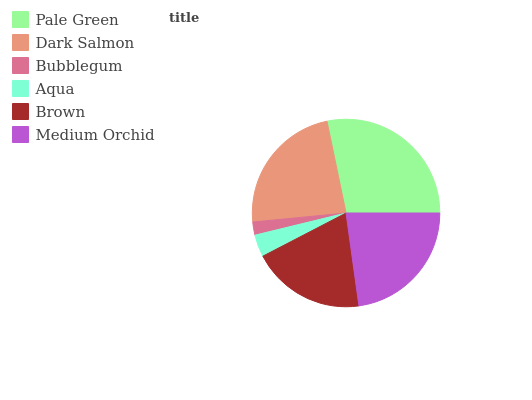Is Bubblegum the minimum?
Answer yes or no. Yes. Is Pale Green the maximum?
Answer yes or no. Yes. Is Dark Salmon the minimum?
Answer yes or no. No. Is Dark Salmon the maximum?
Answer yes or no. No. Is Pale Green greater than Dark Salmon?
Answer yes or no. Yes. Is Dark Salmon less than Pale Green?
Answer yes or no. Yes. Is Dark Salmon greater than Pale Green?
Answer yes or no. No. Is Pale Green less than Dark Salmon?
Answer yes or no. No. Is Medium Orchid the high median?
Answer yes or no. Yes. Is Brown the low median?
Answer yes or no. Yes. Is Aqua the high median?
Answer yes or no. No. Is Aqua the low median?
Answer yes or no. No. 